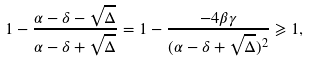<formula> <loc_0><loc_0><loc_500><loc_500>1 - \frac { \alpha - \delta - \sqrt { \Delta } } { \alpha - \delta + \sqrt { \Delta } } = 1 - \frac { - 4 \beta \gamma } { ( \alpha - \delta + \sqrt { \Delta } ) ^ { 2 } } \geqslant 1 ,</formula> 